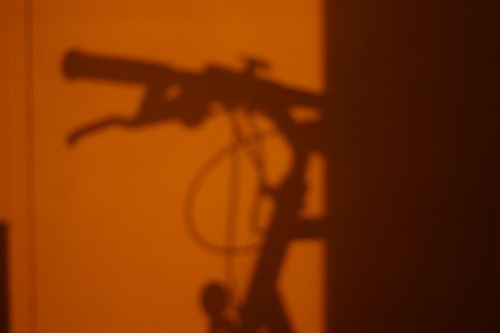Describe the objects in this image and their specific colors. I can see a bicycle in brown, maroon, and red tones in this image. 